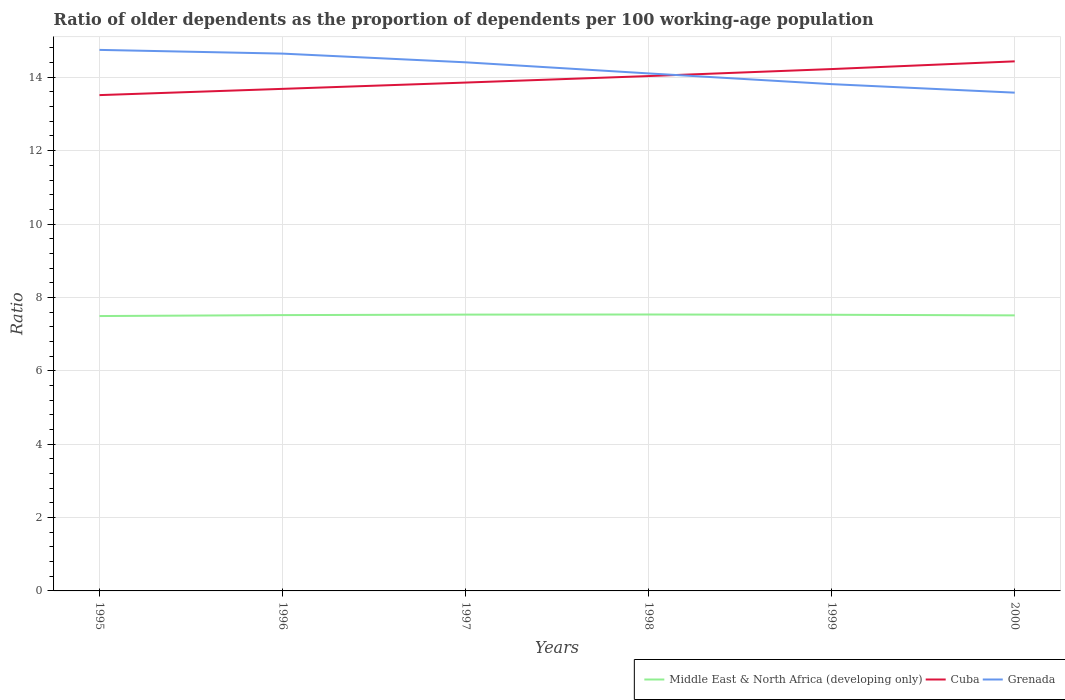How many different coloured lines are there?
Your response must be concise. 3. Across all years, what is the maximum age dependency ratio(old) in Middle East & North Africa (developing only)?
Offer a very short reply. 7.49. In which year was the age dependency ratio(old) in Grenada maximum?
Provide a short and direct response. 2000. What is the total age dependency ratio(old) in Grenada in the graph?
Keep it short and to the point. 0.59. What is the difference between the highest and the second highest age dependency ratio(old) in Middle East & North Africa (developing only)?
Your response must be concise. 0.04. How many lines are there?
Keep it short and to the point. 3. How many years are there in the graph?
Offer a very short reply. 6. Are the values on the major ticks of Y-axis written in scientific E-notation?
Your answer should be very brief. No. How are the legend labels stacked?
Keep it short and to the point. Horizontal. What is the title of the graph?
Give a very brief answer. Ratio of older dependents as the proportion of dependents per 100 working-age population. What is the label or title of the Y-axis?
Make the answer very short. Ratio. What is the Ratio of Middle East & North Africa (developing only) in 1995?
Provide a short and direct response. 7.49. What is the Ratio in Cuba in 1995?
Provide a short and direct response. 13.51. What is the Ratio in Grenada in 1995?
Offer a terse response. 14.75. What is the Ratio in Middle East & North Africa (developing only) in 1996?
Give a very brief answer. 7.52. What is the Ratio in Cuba in 1996?
Offer a terse response. 13.68. What is the Ratio in Grenada in 1996?
Ensure brevity in your answer.  14.64. What is the Ratio in Middle East & North Africa (developing only) in 1997?
Provide a succinct answer. 7.53. What is the Ratio of Cuba in 1997?
Provide a succinct answer. 13.86. What is the Ratio of Grenada in 1997?
Offer a very short reply. 14.41. What is the Ratio of Middle East & North Africa (developing only) in 1998?
Keep it short and to the point. 7.53. What is the Ratio of Cuba in 1998?
Your answer should be very brief. 14.03. What is the Ratio of Grenada in 1998?
Give a very brief answer. 14.11. What is the Ratio in Middle East & North Africa (developing only) in 1999?
Provide a succinct answer. 7.53. What is the Ratio of Cuba in 1999?
Your answer should be compact. 14.22. What is the Ratio in Grenada in 1999?
Offer a very short reply. 13.81. What is the Ratio in Middle East & North Africa (developing only) in 2000?
Your answer should be very brief. 7.51. What is the Ratio in Cuba in 2000?
Give a very brief answer. 14.43. What is the Ratio in Grenada in 2000?
Keep it short and to the point. 13.58. Across all years, what is the maximum Ratio in Middle East & North Africa (developing only)?
Ensure brevity in your answer.  7.53. Across all years, what is the maximum Ratio in Cuba?
Keep it short and to the point. 14.43. Across all years, what is the maximum Ratio of Grenada?
Offer a very short reply. 14.75. Across all years, what is the minimum Ratio in Middle East & North Africa (developing only)?
Provide a short and direct response. 7.49. Across all years, what is the minimum Ratio in Cuba?
Make the answer very short. 13.51. Across all years, what is the minimum Ratio of Grenada?
Offer a very short reply. 13.58. What is the total Ratio of Middle East & North Africa (developing only) in the graph?
Provide a short and direct response. 45.11. What is the total Ratio of Cuba in the graph?
Your answer should be very brief. 83.74. What is the total Ratio of Grenada in the graph?
Your response must be concise. 85.3. What is the difference between the Ratio of Middle East & North Africa (developing only) in 1995 and that in 1996?
Keep it short and to the point. -0.03. What is the difference between the Ratio of Cuba in 1995 and that in 1996?
Your answer should be very brief. -0.17. What is the difference between the Ratio in Grenada in 1995 and that in 1996?
Provide a succinct answer. 0.1. What is the difference between the Ratio of Middle East & North Africa (developing only) in 1995 and that in 1997?
Provide a short and direct response. -0.04. What is the difference between the Ratio in Cuba in 1995 and that in 1997?
Ensure brevity in your answer.  -0.34. What is the difference between the Ratio in Grenada in 1995 and that in 1997?
Offer a very short reply. 0.34. What is the difference between the Ratio in Middle East & North Africa (developing only) in 1995 and that in 1998?
Your answer should be very brief. -0.04. What is the difference between the Ratio in Cuba in 1995 and that in 1998?
Ensure brevity in your answer.  -0.52. What is the difference between the Ratio of Grenada in 1995 and that in 1998?
Make the answer very short. 0.64. What is the difference between the Ratio of Middle East & North Africa (developing only) in 1995 and that in 1999?
Your answer should be very brief. -0.03. What is the difference between the Ratio in Cuba in 1995 and that in 1999?
Your answer should be very brief. -0.71. What is the difference between the Ratio in Grenada in 1995 and that in 1999?
Keep it short and to the point. 0.93. What is the difference between the Ratio in Middle East & North Africa (developing only) in 1995 and that in 2000?
Ensure brevity in your answer.  -0.02. What is the difference between the Ratio of Cuba in 1995 and that in 2000?
Make the answer very short. -0.92. What is the difference between the Ratio of Grenada in 1995 and that in 2000?
Give a very brief answer. 1.17. What is the difference between the Ratio in Middle East & North Africa (developing only) in 1996 and that in 1997?
Provide a succinct answer. -0.01. What is the difference between the Ratio of Cuba in 1996 and that in 1997?
Provide a short and direct response. -0.17. What is the difference between the Ratio in Grenada in 1996 and that in 1997?
Give a very brief answer. 0.24. What is the difference between the Ratio of Middle East & North Africa (developing only) in 1996 and that in 1998?
Provide a succinct answer. -0.02. What is the difference between the Ratio in Cuba in 1996 and that in 1998?
Provide a succinct answer. -0.35. What is the difference between the Ratio in Grenada in 1996 and that in 1998?
Your answer should be very brief. 0.54. What is the difference between the Ratio of Middle East & North Africa (developing only) in 1996 and that in 1999?
Provide a succinct answer. -0.01. What is the difference between the Ratio in Cuba in 1996 and that in 1999?
Your answer should be very brief. -0.54. What is the difference between the Ratio of Grenada in 1996 and that in 1999?
Your answer should be compact. 0.83. What is the difference between the Ratio in Middle East & North Africa (developing only) in 1996 and that in 2000?
Keep it short and to the point. 0.01. What is the difference between the Ratio in Cuba in 1996 and that in 2000?
Give a very brief answer. -0.75. What is the difference between the Ratio of Grenada in 1996 and that in 2000?
Provide a short and direct response. 1.06. What is the difference between the Ratio of Middle East & North Africa (developing only) in 1997 and that in 1998?
Your response must be concise. -0. What is the difference between the Ratio in Cuba in 1997 and that in 1998?
Keep it short and to the point. -0.18. What is the difference between the Ratio of Grenada in 1997 and that in 1998?
Your response must be concise. 0.3. What is the difference between the Ratio of Middle East & North Africa (developing only) in 1997 and that in 1999?
Ensure brevity in your answer.  0. What is the difference between the Ratio in Cuba in 1997 and that in 1999?
Make the answer very short. -0.37. What is the difference between the Ratio of Grenada in 1997 and that in 1999?
Your response must be concise. 0.59. What is the difference between the Ratio of Middle East & North Africa (developing only) in 1997 and that in 2000?
Your answer should be compact. 0.02. What is the difference between the Ratio in Cuba in 1997 and that in 2000?
Keep it short and to the point. -0.58. What is the difference between the Ratio in Grenada in 1997 and that in 2000?
Offer a terse response. 0.83. What is the difference between the Ratio of Middle East & North Africa (developing only) in 1998 and that in 1999?
Your answer should be compact. 0.01. What is the difference between the Ratio of Cuba in 1998 and that in 1999?
Offer a terse response. -0.19. What is the difference between the Ratio of Grenada in 1998 and that in 1999?
Offer a very short reply. 0.29. What is the difference between the Ratio in Middle East & North Africa (developing only) in 1998 and that in 2000?
Your answer should be very brief. 0.02. What is the difference between the Ratio of Cuba in 1998 and that in 2000?
Give a very brief answer. -0.4. What is the difference between the Ratio of Grenada in 1998 and that in 2000?
Ensure brevity in your answer.  0.52. What is the difference between the Ratio in Middle East & North Africa (developing only) in 1999 and that in 2000?
Give a very brief answer. 0.02. What is the difference between the Ratio of Cuba in 1999 and that in 2000?
Offer a very short reply. -0.21. What is the difference between the Ratio in Grenada in 1999 and that in 2000?
Make the answer very short. 0.23. What is the difference between the Ratio of Middle East & North Africa (developing only) in 1995 and the Ratio of Cuba in 1996?
Keep it short and to the point. -6.19. What is the difference between the Ratio in Middle East & North Africa (developing only) in 1995 and the Ratio in Grenada in 1996?
Your answer should be compact. -7.15. What is the difference between the Ratio of Cuba in 1995 and the Ratio of Grenada in 1996?
Your response must be concise. -1.13. What is the difference between the Ratio in Middle East & North Africa (developing only) in 1995 and the Ratio in Cuba in 1997?
Offer a very short reply. -6.36. What is the difference between the Ratio in Middle East & North Africa (developing only) in 1995 and the Ratio in Grenada in 1997?
Offer a very short reply. -6.92. What is the difference between the Ratio of Cuba in 1995 and the Ratio of Grenada in 1997?
Provide a short and direct response. -0.89. What is the difference between the Ratio in Middle East & North Africa (developing only) in 1995 and the Ratio in Cuba in 1998?
Offer a terse response. -6.54. What is the difference between the Ratio of Middle East & North Africa (developing only) in 1995 and the Ratio of Grenada in 1998?
Your answer should be very brief. -6.61. What is the difference between the Ratio of Cuba in 1995 and the Ratio of Grenada in 1998?
Provide a short and direct response. -0.59. What is the difference between the Ratio in Middle East & North Africa (developing only) in 1995 and the Ratio in Cuba in 1999?
Your response must be concise. -6.73. What is the difference between the Ratio of Middle East & North Africa (developing only) in 1995 and the Ratio of Grenada in 1999?
Offer a terse response. -6.32. What is the difference between the Ratio of Cuba in 1995 and the Ratio of Grenada in 1999?
Ensure brevity in your answer.  -0.3. What is the difference between the Ratio in Middle East & North Africa (developing only) in 1995 and the Ratio in Cuba in 2000?
Keep it short and to the point. -6.94. What is the difference between the Ratio of Middle East & North Africa (developing only) in 1995 and the Ratio of Grenada in 2000?
Offer a very short reply. -6.09. What is the difference between the Ratio in Cuba in 1995 and the Ratio in Grenada in 2000?
Your answer should be very brief. -0.07. What is the difference between the Ratio of Middle East & North Africa (developing only) in 1996 and the Ratio of Cuba in 1997?
Ensure brevity in your answer.  -6.34. What is the difference between the Ratio in Middle East & North Africa (developing only) in 1996 and the Ratio in Grenada in 1997?
Give a very brief answer. -6.89. What is the difference between the Ratio in Cuba in 1996 and the Ratio in Grenada in 1997?
Ensure brevity in your answer.  -0.72. What is the difference between the Ratio in Middle East & North Africa (developing only) in 1996 and the Ratio in Cuba in 1998?
Offer a terse response. -6.52. What is the difference between the Ratio of Middle East & North Africa (developing only) in 1996 and the Ratio of Grenada in 1998?
Your answer should be compact. -6.59. What is the difference between the Ratio in Cuba in 1996 and the Ratio in Grenada in 1998?
Keep it short and to the point. -0.42. What is the difference between the Ratio in Middle East & North Africa (developing only) in 1996 and the Ratio in Cuba in 1999?
Your response must be concise. -6.71. What is the difference between the Ratio in Middle East & North Africa (developing only) in 1996 and the Ratio in Grenada in 1999?
Provide a short and direct response. -6.3. What is the difference between the Ratio of Cuba in 1996 and the Ratio of Grenada in 1999?
Keep it short and to the point. -0.13. What is the difference between the Ratio in Middle East & North Africa (developing only) in 1996 and the Ratio in Cuba in 2000?
Provide a short and direct response. -6.92. What is the difference between the Ratio in Middle East & North Africa (developing only) in 1996 and the Ratio in Grenada in 2000?
Provide a succinct answer. -6.06. What is the difference between the Ratio in Cuba in 1996 and the Ratio in Grenada in 2000?
Your answer should be very brief. 0.1. What is the difference between the Ratio of Middle East & North Africa (developing only) in 1997 and the Ratio of Cuba in 1998?
Make the answer very short. -6.5. What is the difference between the Ratio of Middle East & North Africa (developing only) in 1997 and the Ratio of Grenada in 1998?
Provide a short and direct response. -6.57. What is the difference between the Ratio in Cuba in 1997 and the Ratio in Grenada in 1998?
Offer a terse response. -0.25. What is the difference between the Ratio of Middle East & North Africa (developing only) in 1997 and the Ratio of Cuba in 1999?
Offer a terse response. -6.69. What is the difference between the Ratio in Middle East & North Africa (developing only) in 1997 and the Ratio in Grenada in 1999?
Ensure brevity in your answer.  -6.28. What is the difference between the Ratio in Cuba in 1997 and the Ratio in Grenada in 1999?
Give a very brief answer. 0.04. What is the difference between the Ratio in Middle East & North Africa (developing only) in 1997 and the Ratio in Cuba in 2000?
Give a very brief answer. -6.9. What is the difference between the Ratio of Middle East & North Africa (developing only) in 1997 and the Ratio of Grenada in 2000?
Offer a very short reply. -6.05. What is the difference between the Ratio of Cuba in 1997 and the Ratio of Grenada in 2000?
Give a very brief answer. 0.28. What is the difference between the Ratio in Middle East & North Africa (developing only) in 1998 and the Ratio in Cuba in 1999?
Offer a terse response. -6.69. What is the difference between the Ratio in Middle East & North Africa (developing only) in 1998 and the Ratio in Grenada in 1999?
Give a very brief answer. -6.28. What is the difference between the Ratio in Cuba in 1998 and the Ratio in Grenada in 1999?
Make the answer very short. 0.22. What is the difference between the Ratio in Middle East & North Africa (developing only) in 1998 and the Ratio in Cuba in 2000?
Your answer should be very brief. -6.9. What is the difference between the Ratio of Middle East & North Africa (developing only) in 1998 and the Ratio of Grenada in 2000?
Provide a short and direct response. -6.05. What is the difference between the Ratio of Cuba in 1998 and the Ratio of Grenada in 2000?
Keep it short and to the point. 0.45. What is the difference between the Ratio of Middle East & North Africa (developing only) in 1999 and the Ratio of Cuba in 2000?
Ensure brevity in your answer.  -6.91. What is the difference between the Ratio in Middle East & North Africa (developing only) in 1999 and the Ratio in Grenada in 2000?
Make the answer very short. -6.05. What is the difference between the Ratio in Cuba in 1999 and the Ratio in Grenada in 2000?
Your answer should be very brief. 0.64. What is the average Ratio of Middle East & North Africa (developing only) per year?
Keep it short and to the point. 7.52. What is the average Ratio in Cuba per year?
Provide a short and direct response. 13.96. What is the average Ratio in Grenada per year?
Your answer should be very brief. 14.22. In the year 1995, what is the difference between the Ratio of Middle East & North Africa (developing only) and Ratio of Cuba?
Provide a short and direct response. -6.02. In the year 1995, what is the difference between the Ratio in Middle East & North Africa (developing only) and Ratio in Grenada?
Keep it short and to the point. -7.25. In the year 1995, what is the difference between the Ratio in Cuba and Ratio in Grenada?
Provide a short and direct response. -1.23. In the year 1996, what is the difference between the Ratio of Middle East & North Africa (developing only) and Ratio of Cuba?
Give a very brief answer. -6.17. In the year 1996, what is the difference between the Ratio of Middle East & North Africa (developing only) and Ratio of Grenada?
Make the answer very short. -7.13. In the year 1996, what is the difference between the Ratio in Cuba and Ratio in Grenada?
Make the answer very short. -0.96. In the year 1997, what is the difference between the Ratio of Middle East & North Africa (developing only) and Ratio of Cuba?
Your answer should be compact. -6.32. In the year 1997, what is the difference between the Ratio of Middle East & North Africa (developing only) and Ratio of Grenada?
Keep it short and to the point. -6.88. In the year 1997, what is the difference between the Ratio in Cuba and Ratio in Grenada?
Make the answer very short. -0.55. In the year 1998, what is the difference between the Ratio in Middle East & North Africa (developing only) and Ratio in Cuba?
Give a very brief answer. -6.5. In the year 1998, what is the difference between the Ratio of Middle East & North Africa (developing only) and Ratio of Grenada?
Offer a very short reply. -6.57. In the year 1998, what is the difference between the Ratio in Cuba and Ratio in Grenada?
Give a very brief answer. -0.07. In the year 1999, what is the difference between the Ratio in Middle East & North Africa (developing only) and Ratio in Cuba?
Make the answer very short. -6.7. In the year 1999, what is the difference between the Ratio of Middle East & North Africa (developing only) and Ratio of Grenada?
Give a very brief answer. -6.29. In the year 1999, what is the difference between the Ratio of Cuba and Ratio of Grenada?
Your answer should be very brief. 0.41. In the year 2000, what is the difference between the Ratio in Middle East & North Africa (developing only) and Ratio in Cuba?
Your response must be concise. -6.92. In the year 2000, what is the difference between the Ratio in Middle East & North Africa (developing only) and Ratio in Grenada?
Ensure brevity in your answer.  -6.07. In the year 2000, what is the difference between the Ratio in Cuba and Ratio in Grenada?
Offer a terse response. 0.85. What is the ratio of the Ratio in Middle East & North Africa (developing only) in 1995 to that in 1996?
Your answer should be compact. 1. What is the ratio of the Ratio of Cuba in 1995 to that in 1996?
Your response must be concise. 0.99. What is the ratio of the Ratio in Grenada in 1995 to that in 1996?
Keep it short and to the point. 1.01. What is the ratio of the Ratio of Middle East & North Africa (developing only) in 1995 to that in 1997?
Provide a short and direct response. 0.99. What is the ratio of the Ratio in Cuba in 1995 to that in 1997?
Offer a very short reply. 0.98. What is the ratio of the Ratio of Grenada in 1995 to that in 1997?
Offer a terse response. 1.02. What is the ratio of the Ratio of Middle East & North Africa (developing only) in 1995 to that in 1998?
Make the answer very short. 0.99. What is the ratio of the Ratio in Cuba in 1995 to that in 1998?
Your answer should be very brief. 0.96. What is the ratio of the Ratio of Grenada in 1995 to that in 1998?
Provide a succinct answer. 1.05. What is the ratio of the Ratio of Middle East & North Africa (developing only) in 1995 to that in 1999?
Offer a terse response. 1. What is the ratio of the Ratio in Cuba in 1995 to that in 1999?
Offer a terse response. 0.95. What is the ratio of the Ratio in Grenada in 1995 to that in 1999?
Your answer should be compact. 1.07. What is the ratio of the Ratio in Middle East & North Africa (developing only) in 1995 to that in 2000?
Your answer should be compact. 1. What is the ratio of the Ratio in Cuba in 1995 to that in 2000?
Your answer should be very brief. 0.94. What is the ratio of the Ratio of Grenada in 1995 to that in 2000?
Make the answer very short. 1.09. What is the ratio of the Ratio of Cuba in 1996 to that in 1997?
Keep it short and to the point. 0.99. What is the ratio of the Ratio of Grenada in 1996 to that in 1997?
Ensure brevity in your answer.  1.02. What is the ratio of the Ratio in Cuba in 1996 to that in 1998?
Offer a very short reply. 0.98. What is the ratio of the Ratio in Grenada in 1996 to that in 1998?
Your answer should be compact. 1.04. What is the ratio of the Ratio in Cuba in 1996 to that in 1999?
Keep it short and to the point. 0.96. What is the ratio of the Ratio in Grenada in 1996 to that in 1999?
Your answer should be very brief. 1.06. What is the ratio of the Ratio of Middle East & North Africa (developing only) in 1996 to that in 2000?
Your response must be concise. 1. What is the ratio of the Ratio of Cuba in 1996 to that in 2000?
Your answer should be compact. 0.95. What is the ratio of the Ratio in Grenada in 1996 to that in 2000?
Provide a succinct answer. 1.08. What is the ratio of the Ratio of Cuba in 1997 to that in 1998?
Provide a succinct answer. 0.99. What is the ratio of the Ratio of Grenada in 1997 to that in 1998?
Offer a very short reply. 1.02. What is the ratio of the Ratio in Cuba in 1997 to that in 1999?
Offer a terse response. 0.97. What is the ratio of the Ratio of Grenada in 1997 to that in 1999?
Your answer should be compact. 1.04. What is the ratio of the Ratio of Middle East & North Africa (developing only) in 1997 to that in 2000?
Offer a terse response. 1. What is the ratio of the Ratio of Cuba in 1997 to that in 2000?
Your response must be concise. 0.96. What is the ratio of the Ratio in Grenada in 1997 to that in 2000?
Ensure brevity in your answer.  1.06. What is the ratio of the Ratio of Cuba in 1998 to that in 1999?
Make the answer very short. 0.99. What is the ratio of the Ratio of Grenada in 1998 to that in 1999?
Your answer should be very brief. 1.02. What is the ratio of the Ratio of Cuba in 1998 to that in 2000?
Your response must be concise. 0.97. What is the ratio of the Ratio in Grenada in 1998 to that in 2000?
Offer a terse response. 1.04. What is the ratio of the Ratio in Middle East & North Africa (developing only) in 1999 to that in 2000?
Make the answer very short. 1. What is the ratio of the Ratio in Cuba in 1999 to that in 2000?
Your response must be concise. 0.99. What is the ratio of the Ratio of Grenada in 1999 to that in 2000?
Offer a very short reply. 1.02. What is the difference between the highest and the second highest Ratio of Middle East & North Africa (developing only)?
Keep it short and to the point. 0. What is the difference between the highest and the second highest Ratio in Cuba?
Ensure brevity in your answer.  0.21. What is the difference between the highest and the second highest Ratio of Grenada?
Your answer should be compact. 0.1. What is the difference between the highest and the lowest Ratio of Middle East & North Africa (developing only)?
Give a very brief answer. 0.04. What is the difference between the highest and the lowest Ratio of Cuba?
Provide a succinct answer. 0.92. What is the difference between the highest and the lowest Ratio in Grenada?
Keep it short and to the point. 1.17. 